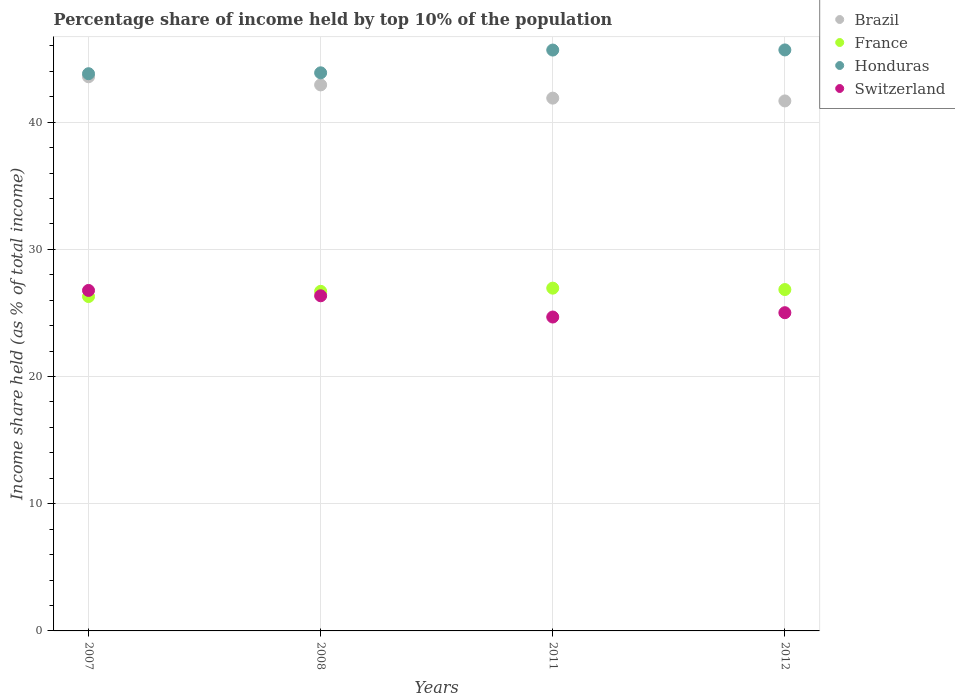How many different coloured dotlines are there?
Keep it short and to the point. 4. What is the percentage share of income held by top 10% of the population in France in 2008?
Offer a terse response. 26.7. Across all years, what is the maximum percentage share of income held by top 10% of the population in Brazil?
Offer a terse response. 43.57. Across all years, what is the minimum percentage share of income held by top 10% of the population in Honduras?
Your answer should be compact. 43.81. What is the total percentage share of income held by top 10% of the population in Brazil in the graph?
Your response must be concise. 170.06. What is the difference between the percentage share of income held by top 10% of the population in Honduras in 2007 and that in 2011?
Provide a short and direct response. -1.86. What is the difference between the percentage share of income held by top 10% of the population in Switzerland in 2012 and the percentage share of income held by top 10% of the population in France in 2008?
Ensure brevity in your answer.  -1.68. What is the average percentage share of income held by top 10% of the population in Switzerland per year?
Offer a terse response. 25.71. In the year 2008, what is the difference between the percentage share of income held by top 10% of the population in Brazil and percentage share of income held by top 10% of the population in Honduras?
Offer a very short reply. -0.95. In how many years, is the percentage share of income held by top 10% of the population in Switzerland greater than 12 %?
Keep it short and to the point. 4. What is the ratio of the percentage share of income held by top 10% of the population in France in 2007 to that in 2008?
Make the answer very short. 0.98. What is the difference between the highest and the second highest percentage share of income held by top 10% of the population in France?
Give a very brief answer. 0.11. What is the difference between the highest and the lowest percentage share of income held by top 10% of the population in Brazil?
Your answer should be compact. 1.9. Is it the case that in every year, the sum of the percentage share of income held by top 10% of the population in Switzerland and percentage share of income held by top 10% of the population in Brazil  is greater than the percentage share of income held by top 10% of the population in France?
Make the answer very short. Yes. Is the percentage share of income held by top 10% of the population in Brazil strictly less than the percentage share of income held by top 10% of the population in France over the years?
Your answer should be very brief. No. Are the values on the major ticks of Y-axis written in scientific E-notation?
Give a very brief answer. No. Does the graph contain any zero values?
Offer a very short reply. No. Does the graph contain grids?
Make the answer very short. Yes. Where does the legend appear in the graph?
Your response must be concise. Top right. What is the title of the graph?
Offer a terse response. Percentage share of income held by top 10% of the population. What is the label or title of the X-axis?
Offer a very short reply. Years. What is the label or title of the Y-axis?
Offer a very short reply. Income share held (as % of total income). What is the Income share held (as % of total income) of Brazil in 2007?
Your answer should be compact. 43.57. What is the Income share held (as % of total income) of France in 2007?
Provide a short and direct response. 26.29. What is the Income share held (as % of total income) of Honduras in 2007?
Provide a succinct answer. 43.81. What is the Income share held (as % of total income) in Switzerland in 2007?
Keep it short and to the point. 26.77. What is the Income share held (as % of total income) of Brazil in 2008?
Provide a succinct answer. 42.93. What is the Income share held (as % of total income) of France in 2008?
Your answer should be compact. 26.7. What is the Income share held (as % of total income) in Honduras in 2008?
Your answer should be very brief. 43.88. What is the Income share held (as % of total income) in Switzerland in 2008?
Keep it short and to the point. 26.35. What is the Income share held (as % of total income) in Brazil in 2011?
Make the answer very short. 41.89. What is the Income share held (as % of total income) of France in 2011?
Provide a succinct answer. 26.95. What is the Income share held (as % of total income) of Honduras in 2011?
Give a very brief answer. 45.67. What is the Income share held (as % of total income) of Switzerland in 2011?
Offer a very short reply. 24.68. What is the Income share held (as % of total income) in Brazil in 2012?
Give a very brief answer. 41.67. What is the Income share held (as % of total income) of France in 2012?
Provide a succinct answer. 26.84. What is the Income share held (as % of total income) in Honduras in 2012?
Your answer should be very brief. 45.68. What is the Income share held (as % of total income) of Switzerland in 2012?
Your response must be concise. 25.02. Across all years, what is the maximum Income share held (as % of total income) of Brazil?
Keep it short and to the point. 43.57. Across all years, what is the maximum Income share held (as % of total income) of France?
Provide a succinct answer. 26.95. Across all years, what is the maximum Income share held (as % of total income) in Honduras?
Give a very brief answer. 45.68. Across all years, what is the maximum Income share held (as % of total income) of Switzerland?
Keep it short and to the point. 26.77. Across all years, what is the minimum Income share held (as % of total income) of Brazil?
Provide a short and direct response. 41.67. Across all years, what is the minimum Income share held (as % of total income) of France?
Provide a short and direct response. 26.29. Across all years, what is the minimum Income share held (as % of total income) in Honduras?
Your answer should be very brief. 43.81. Across all years, what is the minimum Income share held (as % of total income) of Switzerland?
Keep it short and to the point. 24.68. What is the total Income share held (as % of total income) of Brazil in the graph?
Make the answer very short. 170.06. What is the total Income share held (as % of total income) of France in the graph?
Provide a short and direct response. 106.78. What is the total Income share held (as % of total income) of Honduras in the graph?
Keep it short and to the point. 179.04. What is the total Income share held (as % of total income) of Switzerland in the graph?
Your response must be concise. 102.82. What is the difference between the Income share held (as % of total income) in Brazil in 2007 and that in 2008?
Your answer should be very brief. 0.64. What is the difference between the Income share held (as % of total income) of France in 2007 and that in 2008?
Provide a short and direct response. -0.41. What is the difference between the Income share held (as % of total income) of Honduras in 2007 and that in 2008?
Offer a very short reply. -0.07. What is the difference between the Income share held (as % of total income) in Switzerland in 2007 and that in 2008?
Keep it short and to the point. 0.42. What is the difference between the Income share held (as % of total income) of Brazil in 2007 and that in 2011?
Make the answer very short. 1.68. What is the difference between the Income share held (as % of total income) of France in 2007 and that in 2011?
Your answer should be very brief. -0.66. What is the difference between the Income share held (as % of total income) in Honduras in 2007 and that in 2011?
Your answer should be compact. -1.86. What is the difference between the Income share held (as % of total income) in Switzerland in 2007 and that in 2011?
Your answer should be compact. 2.09. What is the difference between the Income share held (as % of total income) in France in 2007 and that in 2012?
Give a very brief answer. -0.55. What is the difference between the Income share held (as % of total income) of Honduras in 2007 and that in 2012?
Offer a very short reply. -1.87. What is the difference between the Income share held (as % of total income) in Switzerland in 2007 and that in 2012?
Your answer should be very brief. 1.75. What is the difference between the Income share held (as % of total income) in France in 2008 and that in 2011?
Keep it short and to the point. -0.25. What is the difference between the Income share held (as % of total income) in Honduras in 2008 and that in 2011?
Your answer should be very brief. -1.79. What is the difference between the Income share held (as % of total income) in Switzerland in 2008 and that in 2011?
Keep it short and to the point. 1.67. What is the difference between the Income share held (as % of total income) in Brazil in 2008 and that in 2012?
Provide a short and direct response. 1.26. What is the difference between the Income share held (as % of total income) of France in 2008 and that in 2012?
Ensure brevity in your answer.  -0.14. What is the difference between the Income share held (as % of total income) in Honduras in 2008 and that in 2012?
Provide a succinct answer. -1.8. What is the difference between the Income share held (as % of total income) of Switzerland in 2008 and that in 2012?
Offer a very short reply. 1.33. What is the difference between the Income share held (as % of total income) in Brazil in 2011 and that in 2012?
Your answer should be compact. 0.22. What is the difference between the Income share held (as % of total income) of France in 2011 and that in 2012?
Your answer should be compact. 0.11. What is the difference between the Income share held (as % of total income) of Honduras in 2011 and that in 2012?
Your answer should be very brief. -0.01. What is the difference between the Income share held (as % of total income) of Switzerland in 2011 and that in 2012?
Provide a short and direct response. -0.34. What is the difference between the Income share held (as % of total income) of Brazil in 2007 and the Income share held (as % of total income) of France in 2008?
Make the answer very short. 16.87. What is the difference between the Income share held (as % of total income) in Brazil in 2007 and the Income share held (as % of total income) in Honduras in 2008?
Give a very brief answer. -0.31. What is the difference between the Income share held (as % of total income) of Brazil in 2007 and the Income share held (as % of total income) of Switzerland in 2008?
Keep it short and to the point. 17.22. What is the difference between the Income share held (as % of total income) of France in 2007 and the Income share held (as % of total income) of Honduras in 2008?
Provide a short and direct response. -17.59. What is the difference between the Income share held (as % of total income) in France in 2007 and the Income share held (as % of total income) in Switzerland in 2008?
Provide a short and direct response. -0.06. What is the difference between the Income share held (as % of total income) of Honduras in 2007 and the Income share held (as % of total income) of Switzerland in 2008?
Your answer should be compact. 17.46. What is the difference between the Income share held (as % of total income) in Brazil in 2007 and the Income share held (as % of total income) in France in 2011?
Offer a very short reply. 16.62. What is the difference between the Income share held (as % of total income) of Brazil in 2007 and the Income share held (as % of total income) of Honduras in 2011?
Make the answer very short. -2.1. What is the difference between the Income share held (as % of total income) of Brazil in 2007 and the Income share held (as % of total income) of Switzerland in 2011?
Provide a short and direct response. 18.89. What is the difference between the Income share held (as % of total income) in France in 2007 and the Income share held (as % of total income) in Honduras in 2011?
Offer a very short reply. -19.38. What is the difference between the Income share held (as % of total income) of France in 2007 and the Income share held (as % of total income) of Switzerland in 2011?
Provide a succinct answer. 1.61. What is the difference between the Income share held (as % of total income) in Honduras in 2007 and the Income share held (as % of total income) in Switzerland in 2011?
Make the answer very short. 19.13. What is the difference between the Income share held (as % of total income) of Brazil in 2007 and the Income share held (as % of total income) of France in 2012?
Provide a succinct answer. 16.73. What is the difference between the Income share held (as % of total income) in Brazil in 2007 and the Income share held (as % of total income) in Honduras in 2012?
Provide a succinct answer. -2.11. What is the difference between the Income share held (as % of total income) of Brazil in 2007 and the Income share held (as % of total income) of Switzerland in 2012?
Provide a succinct answer. 18.55. What is the difference between the Income share held (as % of total income) of France in 2007 and the Income share held (as % of total income) of Honduras in 2012?
Give a very brief answer. -19.39. What is the difference between the Income share held (as % of total income) in France in 2007 and the Income share held (as % of total income) in Switzerland in 2012?
Provide a succinct answer. 1.27. What is the difference between the Income share held (as % of total income) of Honduras in 2007 and the Income share held (as % of total income) of Switzerland in 2012?
Ensure brevity in your answer.  18.79. What is the difference between the Income share held (as % of total income) of Brazil in 2008 and the Income share held (as % of total income) of France in 2011?
Your answer should be very brief. 15.98. What is the difference between the Income share held (as % of total income) in Brazil in 2008 and the Income share held (as % of total income) in Honduras in 2011?
Your answer should be compact. -2.74. What is the difference between the Income share held (as % of total income) in Brazil in 2008 and the Income share held (as % of total income) in Switzerland in 2011?
Your response must be concise. 18.25. What is the difference between the Income share held (as % of total income) in France in 2008 and the Income share held (as % of total income) in Honduras in 2011?
Provide a short and direct response. -18.97. What is the difference between the Income share held (as % of total income) of France in 2008 and the Income share held (as % of total income) of Switzerland in 2011?
Give a very brief answer. 2.02. What is the difference between the Income share held (as % of total income) in Brazil in 2008 and the Income share held (as % of total income) in France in 2012?
Ensure brevity in your answer.  16.09. What is the difference between the Income share held (as % of total income) in Brazil in 2008 and the Income share held (as % of total income) in Honduras in 2012?
Make the answer very short. -2.75. What is the difference between the Income share held (as % of total income) in Brazil in 2008 and the Income share held (as % of total income) in Switzerland in 2012?
Keep it short and to the point. 17.91. What is the difference between the Income share held (as % of total income) of France in 2008 and the Income share held (as % of total income) of Honduras in 2012?
Your answer should be compact. -18.98. What is the difference between the Income share held (as % of total income) of France in 2008 and the Income share held (as % of total income) of Switzerland in 2012?
Provide a succinct answer. 1.68. What is the difference between the Income share held (as % of total income) in Honduras in 2008 and the Income share held (as % of total income) in Switzerland in 2012?
Offer a very short reply. 18.86. What is the difference between the Income share held (as % of total income) of Brazil in 2011 and the Income share held (as % of total income) of France in 2012?
Offer a terse response. 15.05. What is the difference between the Income share held (as % of total income) of Brazil in 2011 and the Income share held (as % of total income) of Honduras in 2012?
Give a very brief answer. -3.79. What is the difference between the Income share held (as % of total income) in Brazil in 2011 and the Income share held (as % of total income) in Switzerland in 2012?
Provide a succinct answer. 16.87. What is the difference between the Income share held (as % of total income) of France in 2011 and the Income share held (as % of total income) of Honduras in 2012?
Provide a short and direct response. -18.73. What is the difference between the Income share held (as % of total income) of France in 2011 and the Income share held (as % of total income) of Switzerland in 2012?
Keep it short and to the point. 1.93. What is the difference between the Income share held (as % of total income) in Honduras in 2011 and the Income share held (as % of total income) in Switzerland in 2012?
Provide a short and direct response. 20.65. What is the average Income share held (as % of total income) in Brazil per year?
Your answer should be compact. 42.52. What is the average Income share held (as % of total income) in France per year?
Provide a short and direct response. 26.7. What is the average Income share held (as % of total income) of Honduras per year?
Keep it short and to the point. 44.76. What is the average Income share held (as % of total income) of Switzerland per year?
Offer a terse response. 25.7. In the year 2007, what is the difference between the Income share held (as % of total income) of Brazil and Income share held (as % of total income) of France?
Provide a short and direct response. 17.28. In the year 2007, what is the difference between the Income share held (as % of total income) in Brazil and Income share held (as % of total income) in Honduras?
Offer a terse response. -0.24. In the year 2007, what is the difference between the Income share held (as % of total income) of Brazil and Income share held (as % of total income) of Switzerland?
Your answer should be very brief. 16.8. In the year 2007, what is the difference between the Income share held (as % of total income) of France and Income share held (as % of total income) of Honduras?
Your response must be concise. -17.52. In the year 2007, what is the difference between the Income share held (as % of total income) of France and Income share held (as % of total income) of Switzerland?
Keep it short and to the point. -0.48. In the year 2007, what is the difference between the Income share held (as % of total income) of Honduras and Income share held (as % of total income) of Switzerland?
Make the answer very short. 17.04. In the year 2008, what is the difference between the Income share held (as % of total income) of Brazil and Income share held (as % of total income) of France?
Offer a terse response. 16.23. In the year 2008, what is the difference between the Income share held (as % of total income) of Brazil and Income share held (as % of total income) of Honduras?
Offer a terse response. -0.95. In the year 2008, what is the difference between the Income share held (as % of total income) in Brazil and Income share held (as % of total income) in Switzerland?
Ensure brevity in your answer.  16.58. In the year 2008, what is the difference between the Income share held (as % of total income) in France and Income share held (as % of total income) in Honduras?
Your answer should be compact. -17.18. In the year 2008, what is the difference between the Income share held (as % of total income) of France and Income share held (as % of total income) of Switzerland?
Offer a terse response. 0.35. In the year 2008, what is the difference between the Income share held (as % of total income) in Honduras and Income share held (as % of total income) in Switzerland?
Your answer should be very brief. 17.53. In the year 2011, what is the difference between the Income share held (as % of total income) of Brazil and Income share held (as % of total income) of France?
Your answer should be compact. 14.94. In the year 2011, what is the difference between the Income share held (as % of total income) of Brazil and Income share held (as % of total income) of Honduras?
Your response must be concise. -3.78. In the year 2011, what is the difference between the Income share held (as % of total income) of Brazil and Income share held (as % of total income) of Switzerland?
Your response must be concise. 17.21. In the year 2011, what is the difference between the Income share held (as % of total income) in France and Income share held (as % of total income) in Honduras?
Give a very brief answer. -18.72. In the year 2011, what is the difference between the Income share held (as % of total income) of France and Income share held (as % of total income) of Switzerland?
Make the answer very short. 2.27. In the year 2011, what is the difference between the Income share held (as % of total income) in Honduras and Income share held (as % of total income) in Switzerland?
Provide a short and direct response. 20.99. In the year 2012, what is the difference between the Income share held (as % of total income) in Brazil and Income share held (as % of total income) in France?
Ensure brevity in your answer.  14.83. In the year 2012, what is the difference between the Income share held (as % of total income) of Brazil and Income share held (as % of total income) of Honduras?
Ensure brevity in your answer.  -4.01. In the year 2012, what is the difference between the Income share held (as % of total income) in Brazil and Income share held (as % of total income) in Switzerland?
Offer a terse response. 16.65. In the year 2012, what is the difference between the Income share held (as % of total income) of France and Income share held (as % of total income) of Honduras?
Make the answer very short. -18.84. In the year 2012, what is the difference between the Income share held (as % of total income) of France and Income share held (as % of total income) of Switzerland?
Your response must be concise. 1.82. In the year 2012, what is the difference between the Income share held (as % of total income) of Honduras and Income share held (as % of total income) of Switzerland?
Ensure brevity in your answer.  20.66. What is the ratio of the Income share held (as % of total income) in Brazil in 2007 to that in 2008?
Ensure brevity in your answer.  1.01. What is the ratio of the Income share held (as % of total income) in France in 2007 to that in 2008?
Offer a terse response. 0.98. What is the ratio of the Income share held (as % of total income) in Switzerland in 2007 to that in 2008?
Your answer should be very brief. 1.02. What is the ratio of the Income share held (as % of total income) of Brazil in 2007 to that in 2011?
Make the answer very short. 1.04. What is the ratio of the Income share held (as % of total income) in France in 2007 to that in 2011?
Provide a succinct answer. 0.98. What is the ratio of the Income share held (as % of total income) of Honduras in 2007 to that in 2011?
Provide a short and direct response. 0.96. What is the ratio of the Income share held (as % of total income) in Switzerland in 2007 to that in 2011?
Keep it short and to the point. 1.08. What is the ratio of the Income share held (as % of total income) of Brazil in 2007 to that in 2012?
Provide a succinct answer. 1.05. What is the ratio of the Income share held (as % of total income) of France in 2007 to that in 2012?
Offer a very short reply. 0.98. What is the ratio of the Income share held (as % of total income) of Honduras in 2007 to that in 2012?
Provide a short and direct response. 0.96. What is the ratio of the Income share held (as % of total income) of Switzerland in 2007 to that in 2012?
Your response must be concise. 1.07. What is the ratio of the Income share held (as % of total income) in Brazil in 2008 to that in 2011?
Your answer should be very brief. 1.02. What is the ratio of the Income share held (as % of total income) in Honduras in 2008 to that in 2011?
Provide a short and direct response. 0.96. What is the ratio of the Income share held (as % of total income) of Switzerland in 2008 to that in 2011?
Provide a short and direct response. 1.07. What is the ratio of the Income share held (as % of total income) of Brazil in 2008 to that in 2012?
Offer a very short reply. 1.03. What is the ratio of the Income share held (as % of total income) in France in 2008 to that in 2012?
Your response must be concise. 0.99. What is the ratio of the Income share held (as % of total income) of Honduras in 2008 to that in 2012?
Your answer should be compact. 0.96. What is the ratio of the Income share held (as % of total income) of Switzerland in 2008 to that in 2012?
Make the answer very short. 1.05. What is the ratio of the Income share held (as % of total income) in Switzerland in 2011 to that in 2012?
Ensure brevity in your answer.  0.99. What is the difference between the highest and the second highest Income share held (as % of total income) of Brazil?
Make the answer very short. 0.64. What is the difference between the highest and the second highest Income share held (as % of total income) in France?
Offer a terse response. 0.11. What is the difference between the highest and the second highest Income share held (as % of total income) in Switzerland?
Offer a very short reply. 0.42. What is the difference between the highest and the lowest Income share held (as % of total income) of Brazil?
Your answer should be compact. 1.9. What is the difference between the highest and the lowest Income share held (as % of total income) in France?
Offer a very short reply. 0.66. What is the difference between the highest and the lowest Income share held (as % of total income) of Honduras?
Keep it short and to the point. 1.87. What is the difference between the highest and the lowest Income share held (as % of total income) of Switzerland?
Give a very brief answer. 2.09. 